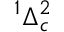<formula> <loc_0><loc_0><loc_500><loc_500>^ { 1 } \Delta _ { c } ^ { 2 }</formula> 